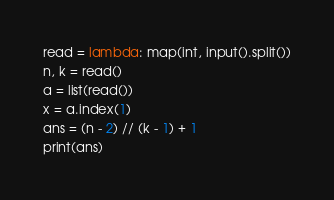Convert code to text. <code><loc_0><loc_0><loc_500><loc_500><_Python_>read = lambda: map(int, input().split())
n, k = read()
a = list(read())
x = a.index(1)
ans = (n - 2) // (k - 1) + 1
print(ans)</code> 